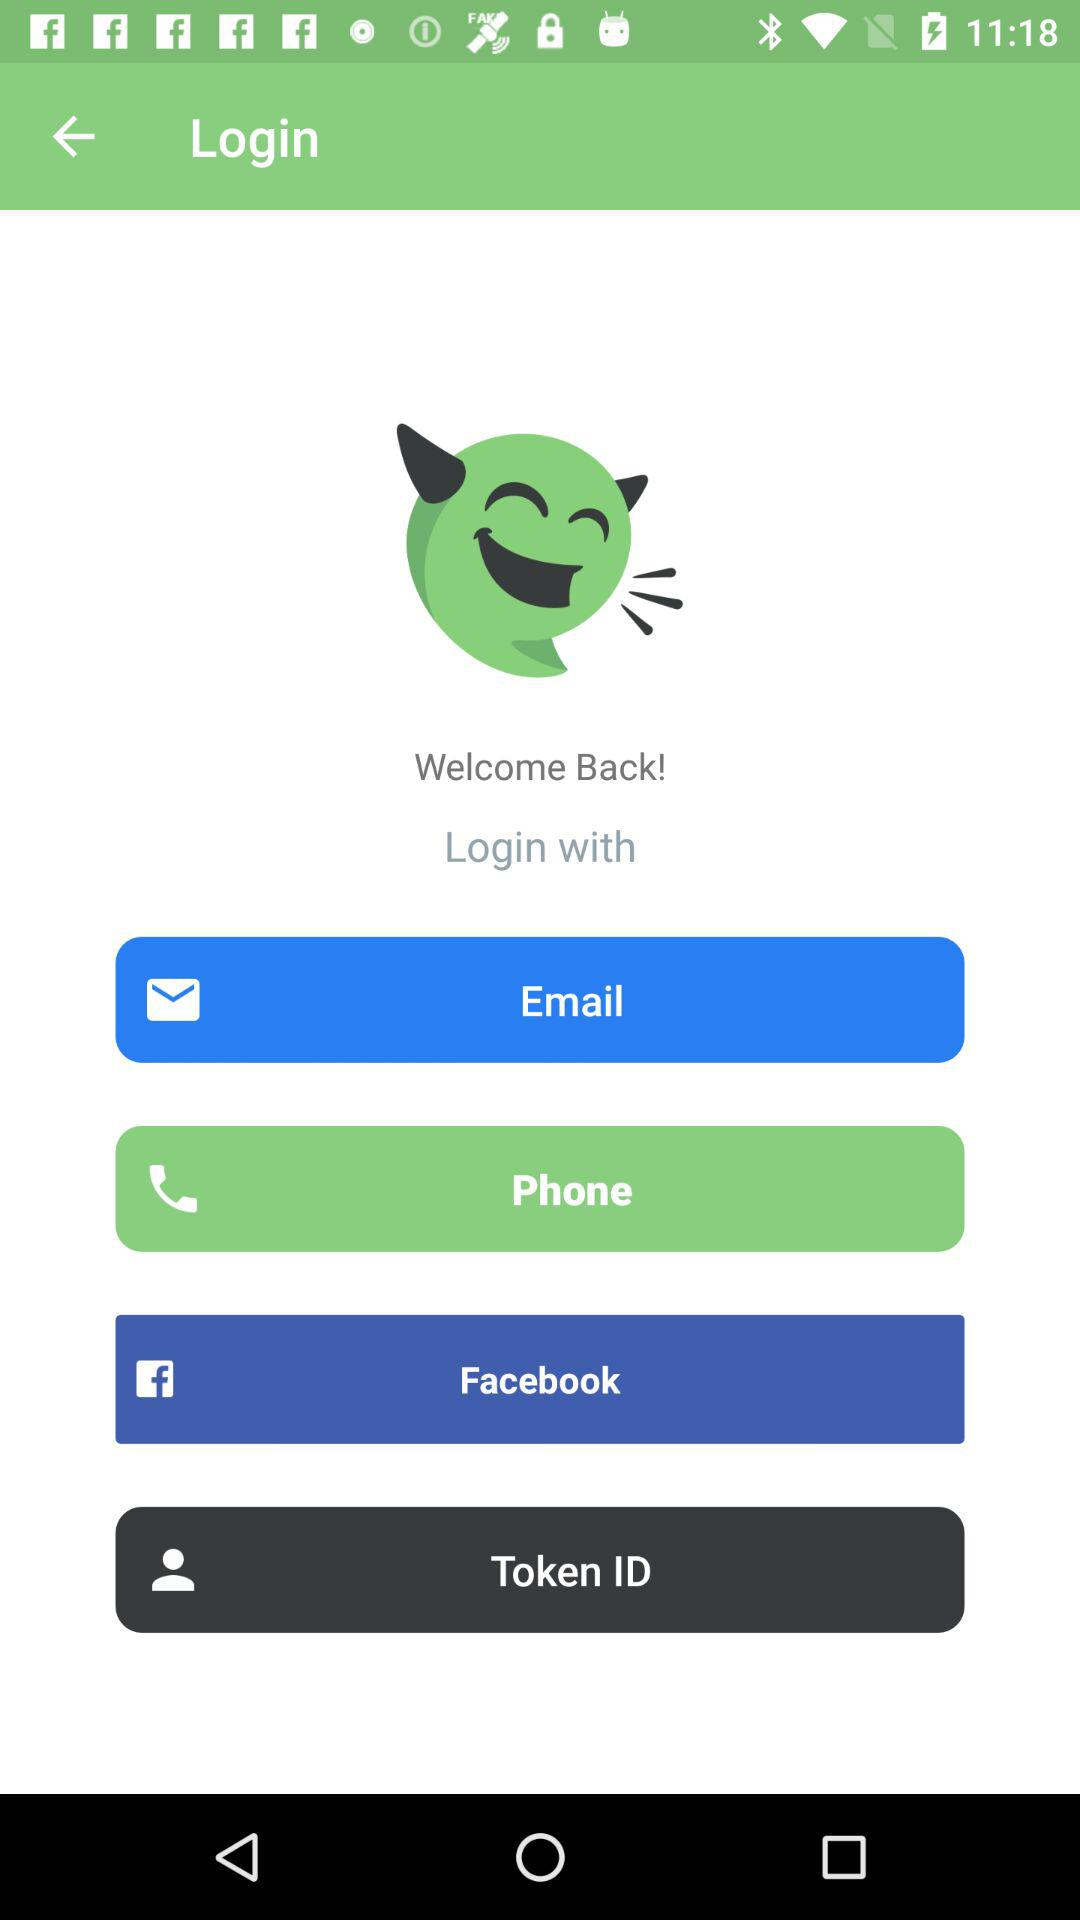Through what app can we log in? You can log in through the "Facebook" app. 